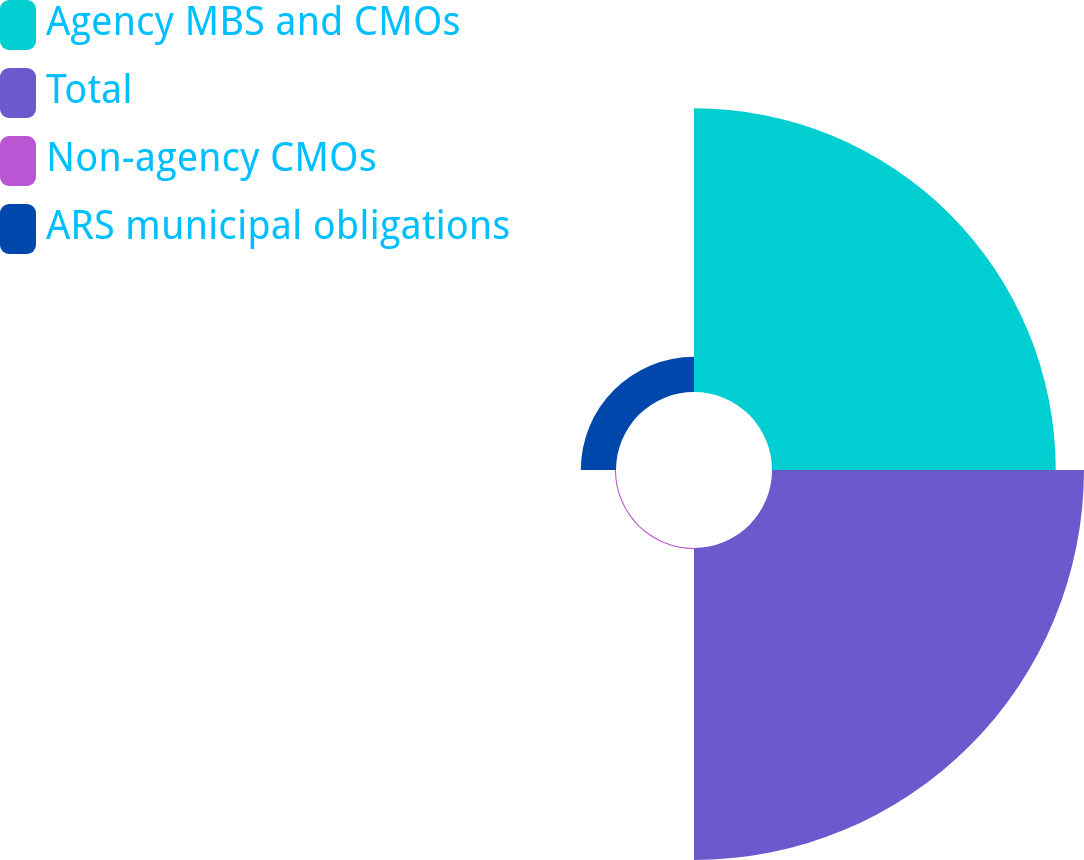Convert chart. <chart><loc_0><loc_0><loc_500><loc_500><pie_chart><fcel>Agency MBS and CMOs<fcel>Total<fcel>Non-agency CMOs<fcel>ARS municipal obligations<nl><fcel>44.9%<fcel>49.37%<fcel>0.17%<fcel>5.57%<nl></chart> 